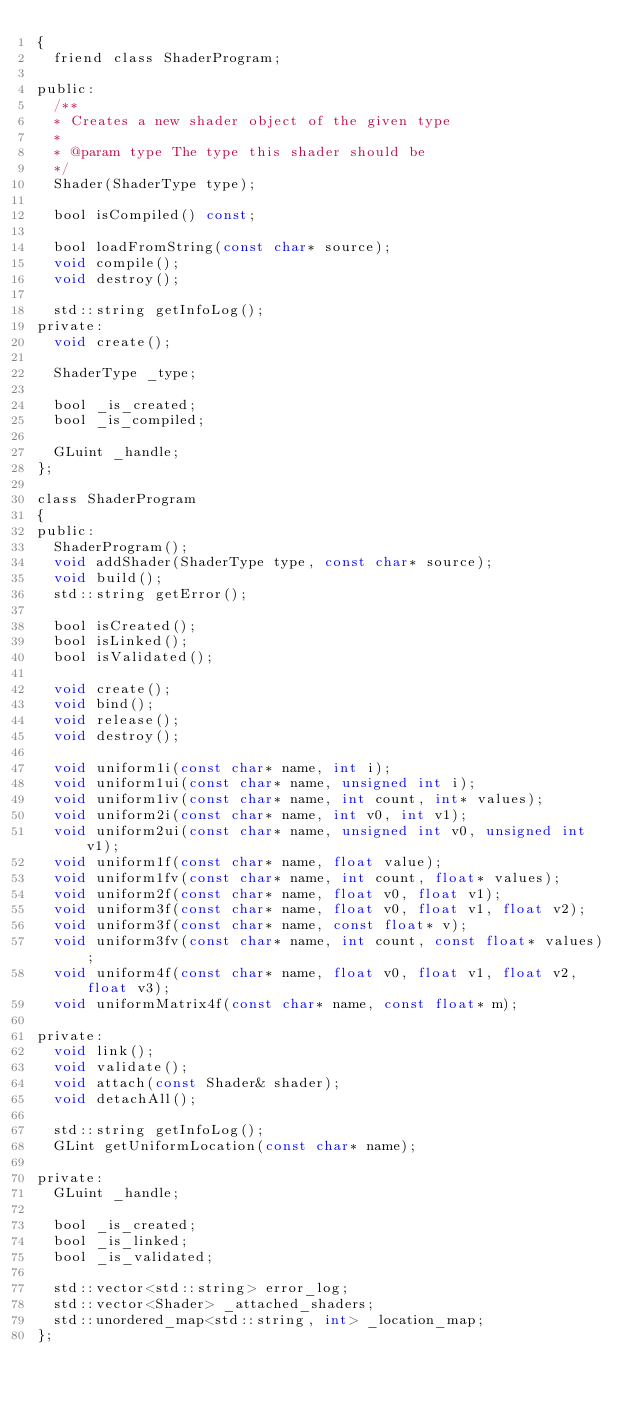<code> <loc_0><loc_0><loc_500><loc_500><_C_>{
  friend class ShaderProgram;

public:
  /**
  * Creates a new shader object of the given type
  *
  * @param type The type this shader should be
  */
  Shader(ShaderType type);

  bool isCompiled() const;

  bool loadFromString(const char* source);
  void compile();
  void destroy();

  std::string getInfoLog();
private:
  void create();

  ShaderType _type;

  bool _is_created;
  bool _is_compiled;

  GLuint _handle;
};

class ShaderProgram
{
public:
  ShaderProgram();
  void addShader(ShaderType type, const char* source);
  void build();
  std::string getError();

  bool isCreated();
  bool isLinked();
  bool isValidated();

  void create();
  void bind();
  void release();
  void destroy();

  void uniform1i(const char* name, int i);
  void uniform1ui(const char* name, unsigned int i);
  void uniform1iv(const char* name, int count, int* values);
  void uniform2i(const char* name, int v0, int v1);
  void uniform2ui(const char* name, unsigned int v0, unsigned int v1);
  void uniform1f(const char* name, float value);
  void uniform1fv(const char* name, int count, float* values);
  void uniform2f(const char* name, float v0, float v1);
  void uniform3f(const char* name, float v0, float v1, float v2);
  void uniform3f(const char* name, const float* v);
  void uniform3fv(const char* name, int count, const float* values);
  void uniform4f(const char* name, float v0, float v1, float v2, float v3);
  void uniformMatrix4f(const char* name, const float* m);

private:
  void link();
  void validate();
  void attach(const Shader& shader);
  void detachAll();

  std::string getInfoLog();
  GLint getUniformLocation(const char* name);

private:
  GLuint _handle;

  bool _is_created;
  bool _is_linked;
  bool _is_validated;

  std::vector<std::string> error_log;
  std::vector<Shader> _attached_shaders;
  std::unordered_map<std::string, int> _location_map;
};
</code> 